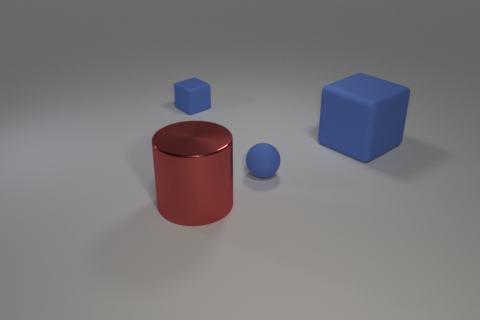What shape is the tiny rubber object on the right side of the blue matte thing that is on the left side of the large metallic cylinder?
Your answer should be compact. Sphere. How many other things are there of the same material as the red cylinder?
Offer a terse response. 0. Does the blue ball have the same material as the tiny object left of the blue ball?
Keep it short and to the point. Yes. What number of objects are metallic things that are on the left side of the sphere or blue matte blocks to the right of the red shiny object?
Make the answer very short. 2. How many other things are there of the same color as the shiny cylinder?
Ensure brevity in your answer.  0. Are there more small blue objects left of the big blue block than things that are behind the large red cylinder?
Provide a short and direct response. No. Is there any other thing that has the same size as the metallic object?
Provide a succinct answer. Yes. How many spheres are either small objects or red things?
Offer a very short reply. 1. What number of objects are either small blue rubber things that are right of the shiny cylinder or large blue rubber cubes?
Keep it short and to the point. 2. What shape is the small matte thing behind the large object that is to the right of the tiny thing in front of the big blue rubber thing?
Your answer should be very brief. Cube. 